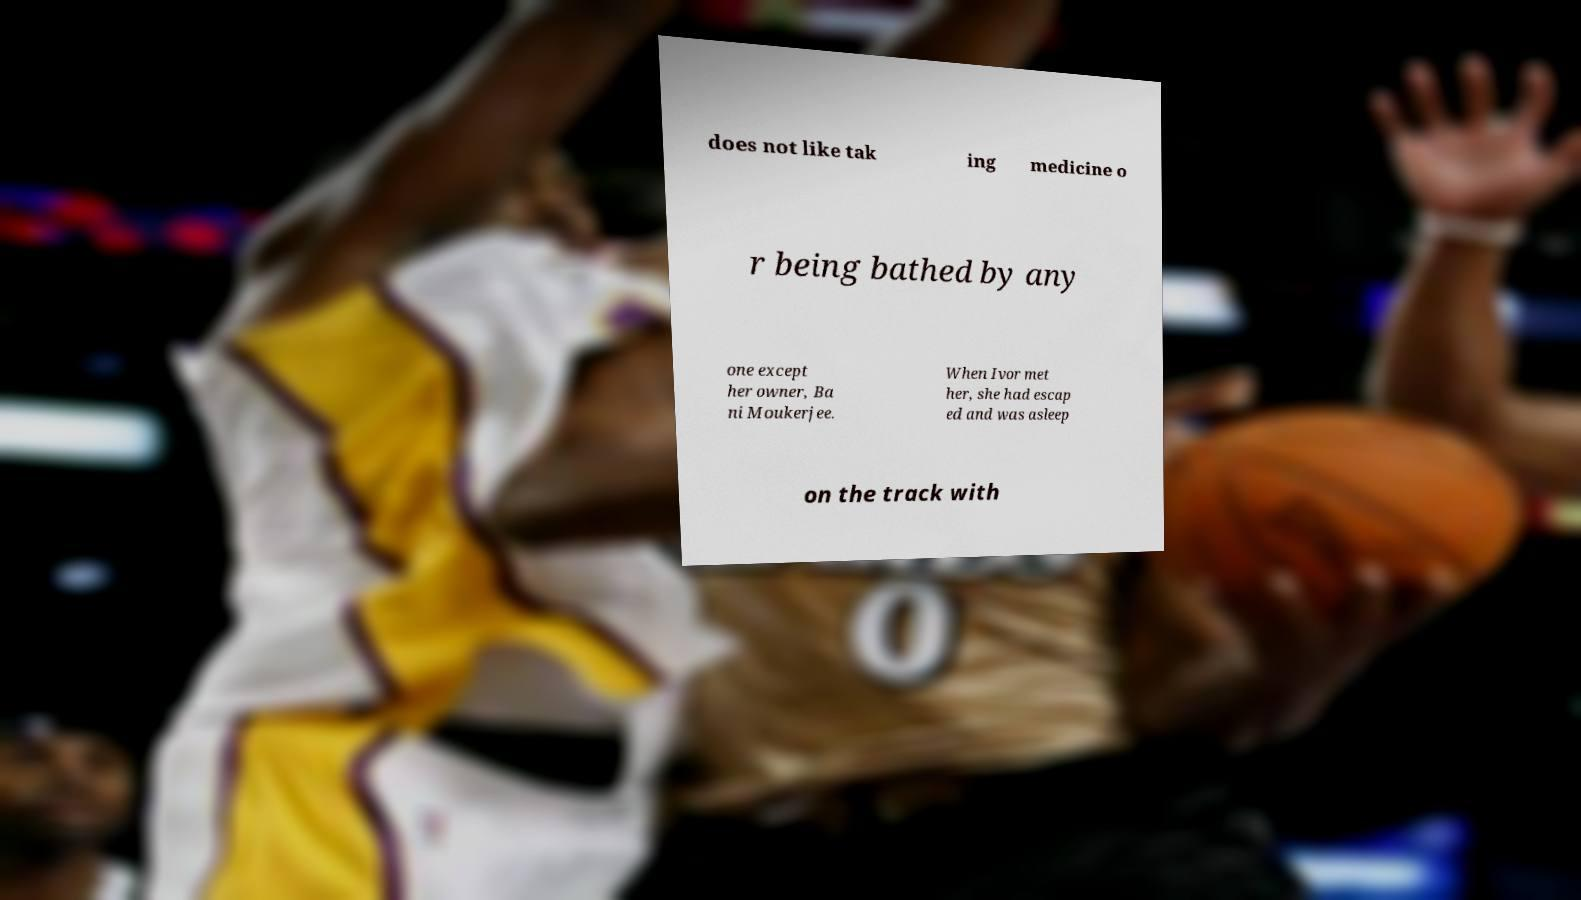Please identify and transcribe the text found in this image. does not like tak ing medicine o r being bathed by any one except her owner, Ba ni Moukerjee. When Ivor met her, she had escap ed and was asleep on the track with 